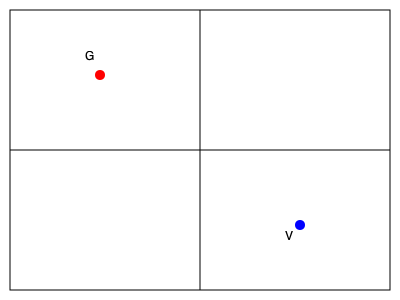Based on the diagram, which strategic positioning approach do Göransson (G) and Verbeek (V) appear to be employing in doubles play, and how does this affect their court coverage? 1. Göransson's position (G):
   - Located in the forecourt on the left side
   - Closer to the net, indicating an aggressive net play strategy

2. Verbeek's position (V):
   - Positioned in the backcourt on the right side
   - Further back, suggesting a baseline defense role

3. This positioning indicates the "Up and Back" formation:
   - One player (Göransson) at the net, the other (Verbeek) at the baseline
   - Allows for both offensive pressure and defensive coverage

4. Benefits of this formation:
   - Göransson can intercept volleys and put pressure on opponents
   - Verbeek can cover the backcourt and handle high shots or lobs

5. Court coverage:
   - Diagonally opposite positions create good court coverage
   - Allows quick transitions between offense and defense

6. Flexibility:
   - Players can switch positions based on serve placement or rally development
   - Adaptable to different opponent strategies

This positioning showcases Göransson and Verbeek's complementary playing styles and their ability to create a balanced doubles strategy that maximizes their strengths in net play and baseline control.
Answer: Up and Back formation 